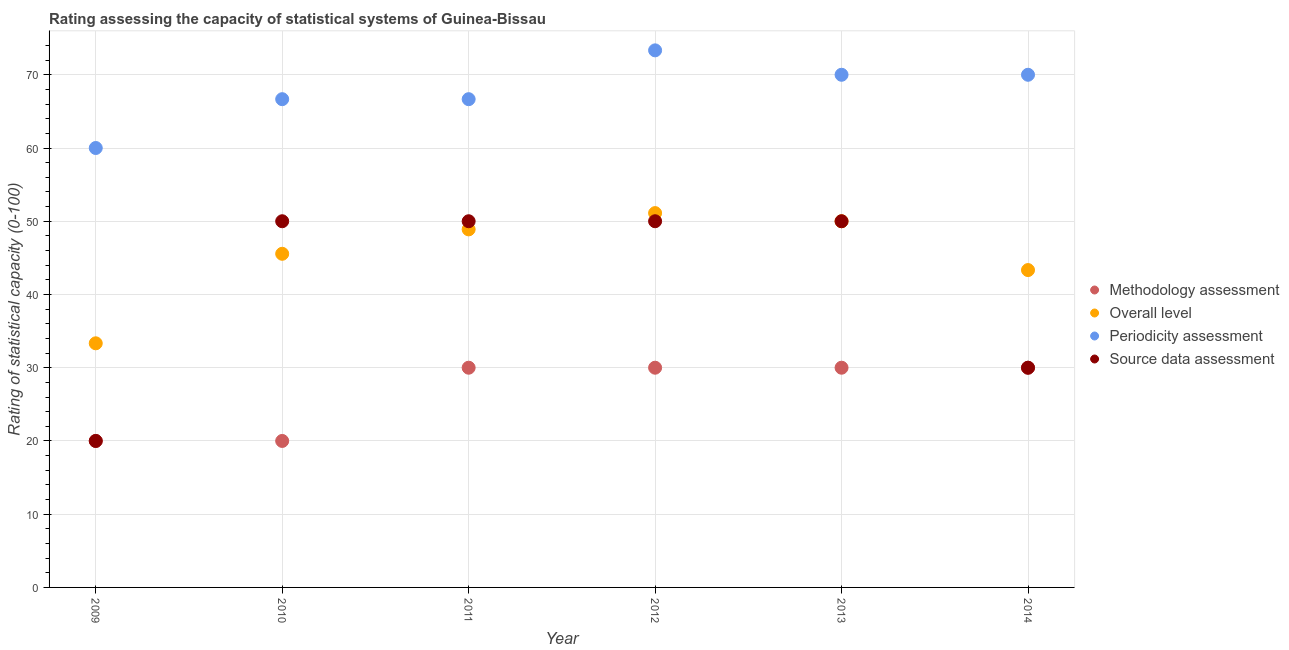Across all years, what is the maximum overall level rating?
Give a very brief answer. 51.11. Across all years, what is the minimum source data assessment rating?
Your response must be concise. 20. In which year was the periodicity assessment rating maximum?
Provide a succinct answer. 2012. What is the total periodicity assessment rating in the graph?
Ensure brevity in your answer.  406.67. What is the difference between the overall level rating in 2011 and the methodology assessment rating in 2014?
Offer a very short reply. 18.89. What is the average methodology assessment rating per year?
Provide a succinct answer. 26.67. In the year 2010, what is the difference between the periodicity assessment rating and source data assessment rating?
Make the answer very short. 16.67. What is the ratio of the overall level rating in 2009 to that in 2012?
Your answer should be compact. 0.65. Is the methodology assessment rating in 2009 less than that in 2010?
Offer a very short reply. No. What is the difference between the highest and the second highest source data assessment rating?
Offer a terse response. 0. What is the difference between the highest and the lowest source data assessment rating?
Offer a very short reply. 30. Does the overall level rating monotonically increase over the years?
Your answer should be very brief. No. Is the methodology assessment rating strictly less than the periodicity assessment rating over the years?
Offer a very short reply. Yes. How many dotlines are there?
Give a very brief answer. 4. What is the difference between two consecutive major ticks on the Y-axis?
Make the answer very short. 10. Does the graph contain any zero values?
Ensure brevity in your answer.  No. Does the graph contain grids?
Ensure brevity in your answer.  Yes. Where does the legend appear in the graph?
Offer a terse response. Center right. How many legend labels are there?
Provide a succinct answer. 4. What is the title of the graph?
Keep it short and to the point. Rating assessing the capacity of statistical systems of Guinea-Bissau. What is the label or title of the Y-axis?
Your answer should be very brief. Rating of statistical capacity (0-100). What is the Rating of statistical capacity (0-100) of Overall level in 2009?
Offer a very short reply. 33.33. What is the Rating of statistical capacity (0-100) in Periodicity assessment in 2009?
Ensure brevity in your answer.  60. What is the Rating of statistical capacity (0-100) of Methodology assessment in 2010?
Your answer should be very brief. 20. What is the Rating of statistical capacity (0-100) in Overall level in 2010?
Keep it short and to the point. 45.56. What is the Rating of statistical capacity (0-100) in Periodicity assessment in 2010?
Your answer should be compact. 66.67. What is the Rating of statistical capacity (0-100) in Methodology assessment in 2011?
Provide a short and direct response. 30. What is the Rating of statistical capacity (0-100) in Overall level in 2011?
Offer a terse response. 48.89. What is the Rating of statistical capacity (0-100) in Periodicity assessment in 2011?
Your answer should be very brief. 66.67. What is the Rating of statistical capacity (0-100) in Source data assessment in 2011?
Provide a short and direct response. 50. What is the Rating of statistical capacity (0-100) in Methodology assessment in 2012?
Give a very brief answer. 30. What is the Rating of statistical capacity (0-100) in Overall level in 2012?
Offer a very short reply. 51.11. What is the Rating of statistical capacity (0-100) in Periodicity assessment in 2012?
Offer a very short reply. 73.33. What is the Rating of statistical capacity (0-100) of Methodology assessment in 2013?
Your response must be concise. 30. What is the Rating of statistical capacity (0-100) of Periodicity assessment in 2013?
Provide a succinct answer. 70. What is the Rating of statistical capacity (0-100) in Overall level in 2014?
Ensure brevity in your answer.  43.33. What is the Rating of statistical capacity (0-100) of Periodicity assessment in 2014?
Provide a short and direct response. 70. Across all years, what is the maximum Rating of statistical capacity (0-100) of Overall level?
Ensure brevity in your answer.  51.11. Across all years, what is the maximum Rating of statistical capacity (0-100) in Periodicity assessment?
Ensure brevity in your answer.  73.33. Across all years, what is the maximum Rating of statistical capacity (0-100) of Source data assessment?
Ensure brevity in your answer.  50. Across all years, what is the minimum Rating of statistical capacity (0-100) in Overall level?
Ensure brevity in your answer.  33.33. Across all years, what is the minimum Rating of statistical capacity (0-100) of Periodicity assessment?
Your answer should be very brief. 60. What is the total Rating of statistical capacity (0-100) of Methodology assessment in the graph?
Offer a terse response. 160. What is the total Rating of statistical capacity (0-100) in Overall level in the graph?
Give a very brief answer. 272.22. What is the total Rating of statistical capacity (0-100) of Periodicity assessment in the graph?
Offer a terse response. 406.67. What is the total Rating of statistical capacity (0-100) in Source data assessment in the graph?
Offer a terse response. 250. What is the difference between the Rating of statistical capacity (0-100) of Overall level in 2009 and that in 2010?
Your answer should be compact. -12.22. What is the difference between the Rating of statistical capacity (0-100) in Periodicity assessment in 2009 and that in 2010?
Give a very brief answer. -6.67. What is the difference between the Rating of statistical capacity (0-100) of Overall level in 2009 and that in 2011?
Offer a very short reply. -15.56. What is the difference between the Rating of statistical capacity (0-100) of Periodicity assessment in 2009 and that in 2011?
Keep it short and to the point. -6.67. What is the difference between the Rating of statistical capacity (0-100) in Methodology assessment in 2009 and that in 2012?
Make the answer very short. -10. What is the difference between the Rating of statistical capacity (0-100) of Overall level in 2009 and that in 2012?
Your answer should be very brief. -17.78. What is the difference between the Rating of statistical capacity (0-100) of Periodicity assessment in 2009 and that in 2012?
Your response must be concise. -13.33. What is the difference between the Rating of statistical capacity (0-100) in Methodology assessment in 2009 and that in 2013?
Ensure brevity in your answer.  -10. What is the difference between the Rating of statistical capacity (0-100) in Overall level in 2009 and that in 2013?
Offer a terse response. -16.67. What is the difference between the Rating of statistical capacity (0-100) in Overall level in 2009 and that in 2014?
Your answer should be compact. -10. What is the difference between the Rating of statistical capacity (0-100) in Periodicity assessment in 2009 and that in 2014?
Provide a short and direct response. -10. What is the difference between the Rating of statistical capacity (0-100) of Source data assessment in 2009 and that in 2014?
Your answer should be compact. -10. What is the difference between the Rating of statistical capacity (0-100) of Source data assessment in 2010 and that in 2011?
Your answer should be very brief. 0. What is the difference between the Rating of statistical capacity (0-100) in Methodology assessment in 2010 and that in 2012?
Provide a succinct answer. -10. What is the difference between the Rating of statistical capacity (0-100) in Overall level in 2010 and that in 2012?
Make the answer very short. -5.56. What is the difference between the Rating of statistical capacity (0-100) in Periodicity assessment in 2010 and that in 2012?
Your answer should be compact. -6.67. What is the difference between the Rating of statistical capacity (0-100) of Methodology assessment in 2010 and that in 2013?
Offer a very short reply. -10. What is the difference between the Rating of statistical capacity (0-100) in Overall level in 2010 and that in 2013?
Keep it short and to the point. -4.44. What is the difference between the Rating of statistical capacity (0-100) of Periodicity assessment in 2010 and that in 2013?
Your answer should be compact. -3.33. What is the difference between the Rating of statistical capacity (0-100) in Overall level in 2010 and that in 2014?
Offer a very short reply. 2.22. What is the difference between the Rating of statistical capacity (0-100) of Periodicity assessment in 2010 and that in 2014?
Ensure brevity in your answer.  -3.33. What is the difference between the Rating of statistical capacity (0-100) of Overall level in 2011 and that in 2012?
Offer a terse response. -2.22. What is the difference between the Rating of statistical capacity (0-100) in Periodicity assessment in 2011 and that in 2012?
Offer a terse response. -6.67. What is the difference between the Rating of statistical capacity (0-100) in Methodology assessment in 2011 and that in 2013?
Offer a very short reply. 0. What is the difference between the Rating of statistical capacity (0-100) of Overall level in 2011 and that in 2013?
Give a very brief answer. -1.11. What is the difference between the Rating of statistical capacity (0-100) of Methodology assessment in 2011 and that in 2014?
Provide a short and direct response. 0. What is the difference between the Rating of statistical capacity (0-100) of Overall level in 2011 and that in 2014?
Your answer should be very brief. 5.56. What is the difference between the Rating of statistical capacity (0-100) in Periodicity assessment in 2012 and that in 2013?
Ensure brevity in your answer.  3.33. What is the difference between the Rating of statistical capacity (0-100) of Overall level in 2012 and that in 2014?
Your answer should be very brief. 7.78. What is the difference between the Rating of statistical capacity (0-100) of Periodicity assessment in 2012 and that in 2014?
Your response must be concise. 3.33. What is the difference between the Rating of statistical capacity (0-100) of Source data assessment in 2013 and that in 2014?
Your answer should be compact. 20. What is the difference between the Rating of statistical capacity (0-100) in Methodology assessment in 2009 and the Rating of statistical capacity (0-100) in Overall level in 2010?
Offer a very short reply. -25.56. What is the difference between the Rating of statistical capacity (0-100) of Methodology assessment in 2009 and the Rating of statistical capacity (0-100) of Periodicity assessment in 2010?
Keep it short and to the point. -46.67. What is the difference between the Rating of statistical capacity (0-100) in Methodology assessment in 2009 and the Rating of statistical capacity (0-100) in Source data assessment in 2010?
Your answer should be compact. -30. What is the difference between the Rating of statistical capacity (0-100) in Overall level in 2009 and the Rating of statistical capacity (0-100) in Periodicity assessment in 2010?
Your response must be concise. -33.33. What is the difference between the Rating of statistical capacity (0-100) of Overall level in 2009 and the Rating of statistical capacity (0-100) of Source data assessment in 2010?
Your response must be concise. -16.67. What is the difference between the Rating of statistical capacity (0-100) in Periodicity assessment in 2009 and the Rating of statistical capacity (0-100) in Source data assessment in 2010?
Provide a succinct answer. 10. What is the difference between the Rating of statistical capacity (0-100) in Methodology assessment in 2009 and the Rating of statistical capacity (0-100) in Overall level in 2011?
Ensure brevity in your answer.  -28.89. What is the difference between the Rating of statistical capacity (0-100) in Methodology assessment in 2009 and the Rating of statistical capacity (0-100) in Periodicity assessment in 2011?
Provide a short and direct response. -46.67. What is the difference between the Rating of statistical capacity (0-100) in Methodology assessment in 2009 and the Rating of statistical capacity (0-100) in Source data assessment in 2011?
Your answer should be very brief. -30. What is the difference between the Rating of statistical capacity (0-100) of Overall level in 2009 and the Rating of statistical capacity (0-100) of Periodicity assessment in 2011?
Offer a very short reply. -33.33. What is the difference between the Rating of statistical capacity (0-100) of Overall level in 2009 and the Rating of statistical capacity (0-100) of Source data assessment in 2011?
Your response must be concise. -16.67. What is the difference between the Rating of statistical capacity (0-100) in Methodology assessment in 2009 and the Rating of statistical capacity (0-100) in Overall level in 2012?
Give a very brief answer. -31.11. What is the difference between the Rating of statistical capacity (0-100) in Methodology assessment in 2009 and the Rating of statistical capacity (0-100) in Periodicity assessment in 2012?
Provide a succinct answer. -53.33. What is the difference between the Rating of statistical capacity (0-100) of Methodology assessment in 2009 and the Rating of statistical capacity (0-100) of Source data assessment in 2012?
Your answer should be compact. -30. What is the difference between the Rating of statistical capacity (0-100) in Overall level in 2009 and the Rating of statistical capacity (0-100) in Source data assessment in 2012?
Make the answer very short. -16.67. What is the difference between the Rating of statistical capacity (0-100) in Periodicity assessment in 2009 and the Rating of statistical capacity (0-100) in Source data assessment in 2012?
Ensure brevity in your answer.  10. What is the difference between the Rating of statistical capacity (0-100) of Methodology assessment in 2009 and the Rating of statistical capacity (0-100) of Source data assessment in 2013?
Make the answer very short. -30. What is the difference between the Rating of statistical capacity (0-100) in Overall level in 2009 and the Rating of statistical capacity (0-100) in Periodicity assessment in 2013?
Your response must be concise. -36.67. What is the difference between the Rating of statistical capacity (0-100) of Overall level in 2009 and the Rating of statistical capacity (0-100) of Source data assessment in 2013?
Offer a terse response. -16.67. What is the difference between the Rating of statistical capacity (0-100) of Periodicity assessment in 2009 and the Rating of statistical capacity (0-100) of Source data assessment in 2013?
Offer a terse response. 10. What is the difference between the Rating of statistical capacity (0-100) in Methodology assessment in 2009 and the Rating of statistical capacity (0-100) in Overall level in 2014?
Provide a short and direct response. -23.33. What is the difference between the Rating of statistical capacity (0-100) of Overall level in 2009 and the Rating of statistical capacity (0-100) of Periodicity assessment in 2014?
Offer a very short reply. -36.67. What is the difference between the Rating of statistical capacity (0-100) in Periodicity assessment in 2009 and the Rating of statistical capacity (0-100) in Source data assessment in 2014?
Give a very brief answer. 30. What is the difference between the Rating of statistical capacity (0-100) of Methodology assessment in 2010 and the Rating of statistical capacity (0-100) of Overall level in 2011?
Keep it short and to the point. -28.89. What is the difference between the Rating of statistical capacity (0-100) of Methodology assessment in 2010 and the Rating of statistical capacity (0-100) of Periodicity assessment in 2011?
Give a very brief answer. -46.67. What is the difference between the Rating of statistical capacity (0-100) of Overall level in 2010 and the Rating of statistical capacity (0-100) of Periodicity assessment in 2011?
Provide a short and direct response. -21.11. What is the difference between the Rating of statistical capacity (0-100) of Overall level in 2010 and the Rating of statistical capacity (0-100) of Source data assessment in 2011?
Your answer should be very brief. -4.44. What is the difference between the Rating of statistical capacity (0-100) of Periodicity assessment in 2010 and the Rating of statistical capacity (0-100) of Source data assessment in 2011?
Make the answer very short. 16.67. What is the difference between the Rating of statistical capacity (0-100) in Methodology assessment in 2010 and the Rating of statistical capacity (0-100) in Overall level in 2012?
Offer a very short reply. -31.11. What is the difference between the Rating of statistical capacity (0-100) in Methodology assessment in 2010 and the Rating of statistical capacity (0-100) in Periodicity assessment in 2012?
Provide a succinct answer. -53.33. What is the difference between the Rating of statistical capacity (0-100) in Overall level in 2010 and the Rating of statistical capacity (0-100) in Periodicity assessment in 2012?
Your answer should be compact. -27.78. What is the difference between the Rating of statistical capacity (0-100) of Overall level in 2010 and the Rating of statistical capacity (0-100) of Source data assessment in 2012?
Make the answer very short. -4.44. What is the difference between the Rating of statistical capacity (0-100) of Periodicity assessment in 2010 and the Rating of statistical capacity (0-100) of Source data assessment in 2012?
Provide a succinct answer. 16.67. What is the difference between the Rating of statistical capacity (0-100) of Overall level in 2010 and the Rating of statistical capacity (0-100) of Periodicity assessment in 2013?
Offer a terse response. -24.44. What is the difference between the Rating of statistical capacity (0-100) in Overall level in 2010 and the Rating of statistical capacity (0-100) in Source data assessment in 2013?
Your answer should be very brief. -4.44. What is the difference between the Rating of statistical capacity (0-100) in Periodicity assessment in 2010 and the Rating of statistical capacity (0-100) in Source data assessment in 2013?
Offer a terse response. 16.67. What is the difference between the Rating of statistical capacity (0-100) of Methodology assessment in 2010 and the Rating of statistical capacity (0-100) of Overall level in 2014?
Your answer should be compact. -23.33. What is the difference between the Rating of statistical capacity (0-100) in Methodology assessment in 2010 and the Rating of statistical capacity (0-100) in Periodicity assessment in 2014?
Make the answer very short. -50. What is the difference between the Rating of statistical capacity (0-100) in Overall level in 2010 and the Rating of statistical capacity (0-100) in Periodicity assessment in 2014?
Give a very brief answer. -24.44. What is the difference between the Rating of statistical capacity (0-100) in Overall level in 2010 and the Rating of statistical capacity (0-100) in Source data assessment in 2014?
Ensure brevity in your answer.  15.56. What is the difference between the Rating of statistical capacity (0-100) of Periodicity assessment in 2010 and the Rating of statistical capacity (0-100) of Source data assessment in 2014?
Provide a short and direct response. 36.67. What is the difference between the Rating of statistical capacity (0-100) of Methodology assessment in 2011 and the Rating of statistical capacity (0-100) of Overall level in 2012?
Offer a very short reply. -21.11. What is the difference between the Rating of statistical capacity (0-100) of Methodology assessment in 2011 and the Rating of statistical capacity (0-100) of Periodicity assessment in 2012?
Give a very brief answer. -43.33. What is the difference between the Rating of statistical capacity (0-100) in Methodology assessment in 2011 and the Rating of statistical capacity (0-100) in Source data assessment in 2012?
Give a very brief answer. -20. What is the difference between the Rating of statistical capacity (0-100) of Overall level in 2011 and the Rating of statistical capacity (0-100) of Periodicity assessment in 2012?
Offer a terse response. -24.44. What is the difference between the Rating of statistical capacity (0-100) in Overall level in 2011 and the Rating of statistical capacity (0-100) in Source data assessment in 2012?
Offer a very short reply. -1.11. What is the difference between the Rating of statistical capacity (0-100) of Periodicity assessment in 2011 and the Rating of statistical capacity (0-100) of Source data assessment in 2012?
Your answer should be compact. 16.67. What is the difference between the Rating of statistical capacity (0-100) of Methodology assessment in 2011 and the Rating of statistical capacity (0-100) of Source data assessment in 2013?
Give a very brief answer. -20. What is the difference between the Rating of statistical capacity (0-100) in Overall level in 2011 and the Rating of statistical capacity (0-100) in Periodicity assessment in 2013?
Your answer should be very brief. -21.11. What is the difference between the Rating of statistical capacity (0-100) in Overall level in 2011 and the Rating of statistical capacity (0-100) in Source data assessment in 2013?
Your answer should be very brief. -1.11. What is the difference between the Rating of statistical capacity (0-100) in Periodicity assessment in 2011 and the Rating of statistical capacity (0-100) in Source data assessment in 2013?
Offer a terse response. 16.67. What is the difference between the Rating of statistical capacity (0-100) of Methodology assessment in 2011 and the Rating of statistical capacity (0-100) of Overall level in 2014?
Offer a terse response. -13.33. What is the difference between the Rating of statistical capacity (0-100) in Methodology assessment in 2011 and the Rating of statistical capacity (0-100) in Source data assessment in 2014?
Make the answer very short. 0. What is the difference between the Rating of statistical capacity (0-100) of Overall level in 2011 and the Rating of statistical capacity (0-100) of Periodicity assessment in 2014?
Your response must be concise. -21.11. What is the difference between the Rating of statistical capacity (0-100) in Overall level in 2011 and the Rating of statistical capacity (0-100) in Source data assessment in 2014?
Your response must be concise. 18.89. What is the difference between the Rating of statistical capacity (0-100) in Periodicity assessment in 2011 and the Rating of statistical capacity (0-100) in Source data assessment in 2014?
Offer a very short reply. 36.67. What is the difference between the Rating of statistical capacity (0-100) of Methodology assessment in 2012 and the Rating of statistical capacity (0-100) of Overall level in 2013?
Ensure brevity in your answer.  -20. What is the difference between the Rating of statistical capacity (0-100) in Overall level in 2012 and the Rating of statistical capacity (0-100) in Periodicity assessment in 2013?
Ensure brevity in your answer.  -18.89. What is the difference between the Rating of statistical capacity (0-100) of Periodicity assessment in 2012 and the Rating of statistical capacity (0-100) of Source data assessment in 2013?
Offer a very short reply. 23.33. What is the difference between the Rating of statistical capacity (0-100) of Methodology assessment in 2012 and the Rating of statistical capacity (0-100) of Overall level in 2014?
Your answer should be compact. -13.33. What is the difference between the Rating of statistical capacity (0-100) in Overall level in 2012 and the Rating of statistical capacity (0-100) in Periodicity assessment in 2014?
Ensure brevity in your answer.  -18.89. What is the difference between the Rating of statistical capacity (0-100) in Overall level in 2012 and the Rating of statistical capacity (0-100) in Source data assessment in 2014?
Your answer should be very brief. 21.11. What is the difference between the Rating of statistical capacity (0-100) in Periodicity assessment in 2012 and the Rating of statistical capacity (0-100) in Source data assessment in 2014?
Offer a very short reply. 43.33. What is the difference between the Rating of statistical capacity (0-100) of Methodology assessment in 2013 and the Rating of statistical capacity (0-100) of Overall level in 2014?
Keep it short and to the point. -13.33. What is the difference between the Rating of statistical capacity (0-100) in Overall level in 2013 and the Rating of statistical capacity (0-100) in Periodicity assessment in 2014?
Provide a short and direct response. -20. What is the difference between the Rating of statistical capacity (0-100) in Overall level in 2013 and the Rating of statistical capacity (0-100) in Source data assessment in 2014?
Your response must be concise. 20. What is the average Rating of statistical capacity (0-100) of Methodology assessment per year?
Offer a terse response. 26.67. What is the average Rating of statistical capacity (0-100) in Overall level per year?
Provide a short and direct response. 45.37. What is the average Rating of statistical capacity (0-100) of Periodicity assessment per year?
Offer a very short reply. 67.78. What is the average Rating of statistical capacity (0-100) in Source data assessment per year?
Give a very brief answer. 41.67. In the year 2009, what is the difference between the Rating of statistical capacity (0-100) of Methodology assessment and Rating of statistical capacity (0-100) of Overall level?
Offer a terse response. -13.33. In the year 2009, what is the difference between the Rating of statistical capacity (0-100) in Methodology assessment and Rating of statistical capacity (0-100) in Periodicity assessment?
Provide a succinct answer. -40. In the year 2009, what is the difference between the Rating of statistical capacity (0-100) in Methodology assessment and Rating of statistical capacity (0-100) in Source data assessment?
Your answer should be very brief. 0. In the year 2009, what is the difference between the Rating of statistical capacity (0-100) of Overall level and Rating of statistical capacity (0-100) of Periodicity assessment?
Your response must be concise. -26.67. In the year 2009, what is the difference between the Rating of statistical capacity (0-100) of Overall level and Rating of statistical capacity (0-100) of Source data assessment?
Give a very brief answer. 13.33. In the year 2010, what is the difference between the Rating of statistical capacity (0-100) in Methodology assessment and Rating of statistical capacity (0-100) in Overall level?
Ensure brevity in your answer.  -25.56. In the year 2010, what is the difference between the Rating of statistical capacity (0-100) of Methodology assessment and Rating of statistical capacity (0-100) of Periodicity assessment?
Keep it short and to the point. -46.67. In the year 2010, what is the difference between the Rating of statistical capacity (0-100) of Methodology assessment and Rating of statistical capacity (0-100) of Source data assessment?
Ensure brevity in your answer.  -30. In the year 2010, what is the difference between the Rating of statistical capacity (0-100) of Overall level and Rating of statistical capacity (0-100) of Periodicity assessment?
Your response must be concise. -21.11. In the year 2010, what is the difference between the Rating of statistical capacity (0-100) of Overall level and Rating of statistical capacity (0-100) of Source data assessment?
Keep it short and to the point. -4.44. In the year 2010, what is the difference between the Rating of statistical capacity (0-100) of Periodicity assessment and Rating of statistical capacity (0-100) of Source data assessment?
Make the answer very short. 16.67. In the year 2011, what is the difference between the Rating of statistical capacity (0-100) in Methodology assessment and Rating of statistical capacity (0-100) in Overall level?
Your response must be concise. -18.89. In the year 2011, what is the difference between the Rating of statistical capacity (0-100) of Methodology assessment and Rating of statistical capacity (0-100) of Periodicity assessment?
Provide a short and direct response. -36.67. In the year 2011, what is the difference between the Rating of statistical capacity (0-100) in Overall level and Rating of statistical capacity (0-100) in Periodicity assessment?
Keep it short and to the point. -17.78. In the year 2011, what is the difference between the Rating of statistical capacity (0-100) of Overall level and Rating of statistical capacity (0-100) of Source data assessment?
Your answer should be very brief. -1.11. In the year 2011, what is the difference between the Rating of statistical capacity (0-100) in Periodicity assessment and Rating of statistical capacity (0-100) in Source data assessment?
Your answer should be compact. 16.67. In the year 2012, what is the difference between the Rating of statistical capacity (0-100) of Methodology assessment and Rating of statistical capacity (0-100) of Overall level?
Offer a terse response. -21.11. In the year 2012, what is the difference between the Rating of statistical capacity (0-100) of Methodology assessment and Rating of statistical capacity (0-100) of Periodicity assessment?
Offer a very short reply. -43.33. In the year 2012, what is the difference between the Rating of statistical capacity (0-100) in Overall level and Rating of statistical capacity (0-100) in Periodicity assessment?
Provide a short and direct response. -22.22. In the year 2012, what is the difference between the Rating of statistical capacity (0-100) in Overall level and Rating of statistical capacity (0-100) in Source data assessment?
Provide a succinct answer. 1.11. In the year 2012, what is the difference between the Rating of statistical capacity (0-100) in Periodicity assessment and Rating of statistical capacity (0-100) in Source data assessment?
Provide a short and direct response. 23.33. In the year 2013, what is the difference between the Rating of statistical capacity (0-100) in Methodology assessment and Rating of statistical capacity (0-100) in Source data assessment?
Offer a terse response. -20. In the year 2013, what is the difference between the Rating of statistical capacity (0-100) in Overall level and Rating of statistical capacity (0-100) in Periodicity assessment?
Provide a short and direct response. -20. In the year 2013, what is the difference between the Rating of statistical capacity (0-100) in Periodicity assessment and Rating of statistical capacity (0-100) in Source data assessment?
Make the answer very short. 20. In the year 2014, what is the difference between the Rating of statistical capacity (0-100) of Methodology assessment and Rating of statistical capacity (0-100) of Overall level?
Give a very brief answer. -13.33. In the year 2014, what is the difference between the Rating of statistical capacity (0-100) in Methodology assessment and Rating of statistical capacity (0-100) in Periodicity assessment?
Offer a terse response. -40. In the year 2014, what is the difference between the Rating of statistical capacity (0-100) of Methodology assessment and Rating of statistical capacity (0-100) of Source data assessment?
Make the answer very short. 0. In the year 2014, what is the difference between the Rating of statistical capacity (0-100) of Overall level and Rating of statistical capacity (0-100) of Periodicity assessment?
Give a very brief answer. -26.67. In the year 2014, what is the difference between the Rating of statistical capacity (0-100) of Overall level and Rating of statistical capacity (0-100) of Source data assessment?
Keep it short and to the point. 13.33. What is the ratio of the Rating of statistical capacity (0-100) in Methodology assessment in 2009 to that in 2010?
Keep it short and to the point. 1. What is the ratio of the Rating of statistical capacity (0-100) in Overall level in 2009 to that in 2010?
Keep it short and to the point. 0.73. What is the ratio of the Rating of statistical capacity (0-100) of Periodicity assessment in 2009 to that in 2010?
Offer a terse response. 0.9. What is the ratio of the Rating of statistical capacity (0-100) of Source data assessment in 2009 to that in 2010?
Provide a succinct answer. 0.4. What is the ratio of the Rating of statistical capacity (0-100) in Methodology assessment in 2009 to that in 2011?
Keep it short and to the point. 0.67. What is the ratio of the Rating of statistical capacity (0-100) in Overall level in 2009 to that in 2011?
Ensure brevity in your answer.  0.68. What is the ratio of the Rating of statistical capacity (0-100) in Periodicity assessment in 2009 to that in 2011?
Ensure brevity in your answer.  0.9. What is the ratio of the Rating of statistical capacity (0-100) of Source data assessment in 2009 to that in 2011?
Provide a short and direct response. 0.4. What is the ratio of the Rating of statistical capacity (0-100) of Overall level in 2009 to that in 2012?
Ensure brevity in your answer.  0.65. What is the ratio of the Rating of statistical capacity (0-100) of Periodicity assessment in 2009 to that in 2012?
Your answer should be compact. 0.82. What is the ratio of the Rating of statistical capacity (0-100) of Methodology assessment in 2009 to that in 2013?
Your answer should be very brief. 0.67. What is the ratio of the Rating of statistical capacity (0-100) of Overall level in 2009 to that in 2013?
Your answer should be very brief. 0.67. What is the ratio of the Rating of statistical capacity (0-100) of Methodology assessment in 2009 to that in 2014?
Your response must be concise. 0.67. What is the ratio of the Rating of statistical capacity (0-100) of Overall level in 2009 to that in 2014?
Ensure brevity in your answer.  0.77. What is the ratio of the Rating of statistical capacity (0-100) in Periodicity assessment in 2009 to that in 2014?
Provide a short and direct response. 0.86. What is the ratio of the Rating of statistical capacity (0-100) in Overall level in 2010 to that in 2011?
Keep it short and to the point. 0.93. What is the ratio of the Rating of statistical capacity (0-100) of Periodicity assessment in 2010 to that in 2011?
Offer a terse response. 1. What is the ratio of the Rating of statistical capacity (0-100) in Overall level in 2010 to that in 2012?
Your answer should be compact. 0.89. What is the ratio of the Rating of statistical capacity (0-100) in Periodicity assessment in 2010 to that in 2012?
Provide a succinct answer. 0.91. What is the ratio of the Rating of statistical capacity (0-100) in Methodology assessment in 2010 to that in 2013?
Provide a short and direct response. 0.67. What is the ratio of the Rating of statistical capacity (0-100) in Overall level in 2010 to that in 2013?
Provide a succinct answer. 0.91. What is the ratio of the Rating of statistical capacity (0-100) in Source data assessment in 2010 to that in 2013?
Provide a succinct answer. 1. What is the ratio of the Rating of statistical capacity (0-100) in Overall level in 2010 to that in 2014?
Keep it short and to the point. 1.05. What is the ratio of the Rating of statistical capacity (0-100) of Periodicity assessment in 2010 to that in 2014?
Your response must be concise. 0.95. What is the ratio of the Rating of statistical capacity (0-100) of Overall level in 2011 to that in 2012?
Offer a terse response. 0.96. What is the ratio of the Rating of statistical capacity (0-100) of Periodicity assessment in 2011 to that in 2012?
Give a very brief answer. 0.91. What is the ratio of the Rating of statistical capacity (0-100) of Methodology assessment in 2011 to that in 2013?
Offer a very short reply. 1. What is the ratio of the Rating of statistical capacity (0-100) of Overall level in 2011 to that in 2013?
Your response must be concise. 0.98. What is the ratio of the Rating of statistical capacity (0-100) in Overall level in 2011 to that in 2014?
Offer a terse response. 1.13. What is the ratio of the Rating of statistical capacity (0-100) in Periodicity assessment in 2011 to that in 2014?
Your answer should be very brief. 0.95. What is the ratio of the Rating of statistical capacity (0-100) of Source data assessment in 2011 to that in 2014?
Your answer should be compact. 1.67. What is the ratio of the Rating of statistical capacity (0-100) of Methodology assessment in 2012 to that in 2013?
Keep it short and to the point. 1. What is the ratio of the Rating of statistical capacity (0-100) of Overall level in 2012 to that in 2013?
Provide a succinct answer. 1.02. What is the ratio of the Rating of statistical capacity (0-100) of Periodicity assessment in 2012 to that in 2013?
Give a very brief answer. 1.05. What is the ratio of the Rating of statistical capacity (0-100) in Source data assessment in 2012 to that in 2013?
Keep it short and to the point. 1. What is the ratio of the Rating of statistical capacity (0-100) in Methodology assessment in 2012 to that in 2014?
Keep it short and to the point. 1. What is the ratio of the Rating of statistical capacity (0-100) of Overall level in 2012 to that in 2014?
Give a very brief answer. 1.18. What is the ratio of the Rating of statistical capacity (0-100) in Periodicity assessment in 2012 to that in 2014?
Your answer should be compact. 1.05. What is the ratio of the Rating of statistical capacity (0-100) of Overall level in 2013 to that in 2014?
Offer a terse response. 1.15. What is the ratio of the Rating of statistical capacity (0-100) in Periodicity assessment in 2013 to that in 2014?
Offer a very short reply. 1. What is the difference between the highest and the second highest Rating of statistical capacity (0-100) of Methodology assessment?
Provide a succinct answer. 0. What is the difference between the highest and the second highest Rating of statistical capacity (0-100) of Source data assessment?
Provide a succinct answer. 0. What is the difference between the highest and the lowest Rating of statistical capacity (0-100) in Overall level?
Offer a terse response. 17.78. What is the difference between the highest and the lowest Rating of statistical capacity (0-100) in Periodicity assessment?
Your answer should be compact. 13.33. 